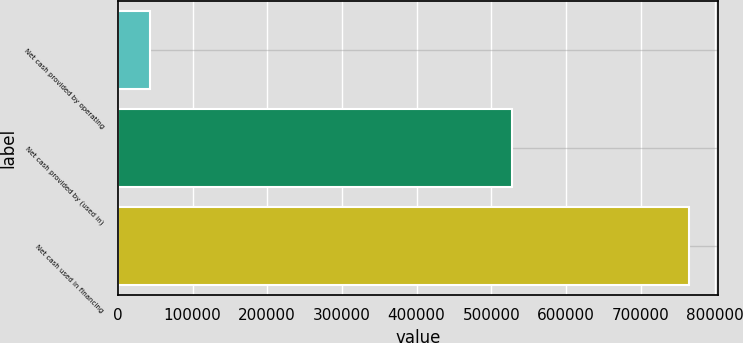Convert chart. <chart><loc_0><loc_0><loc_500><loc_500><bar_chart><fcel>Net cash provided by operating<fcel>Net cash provided by (used in)<fcel>Net cash used in financing<nl><fcel>42743<fcel>527619<fcel>764868<nl></chart> 